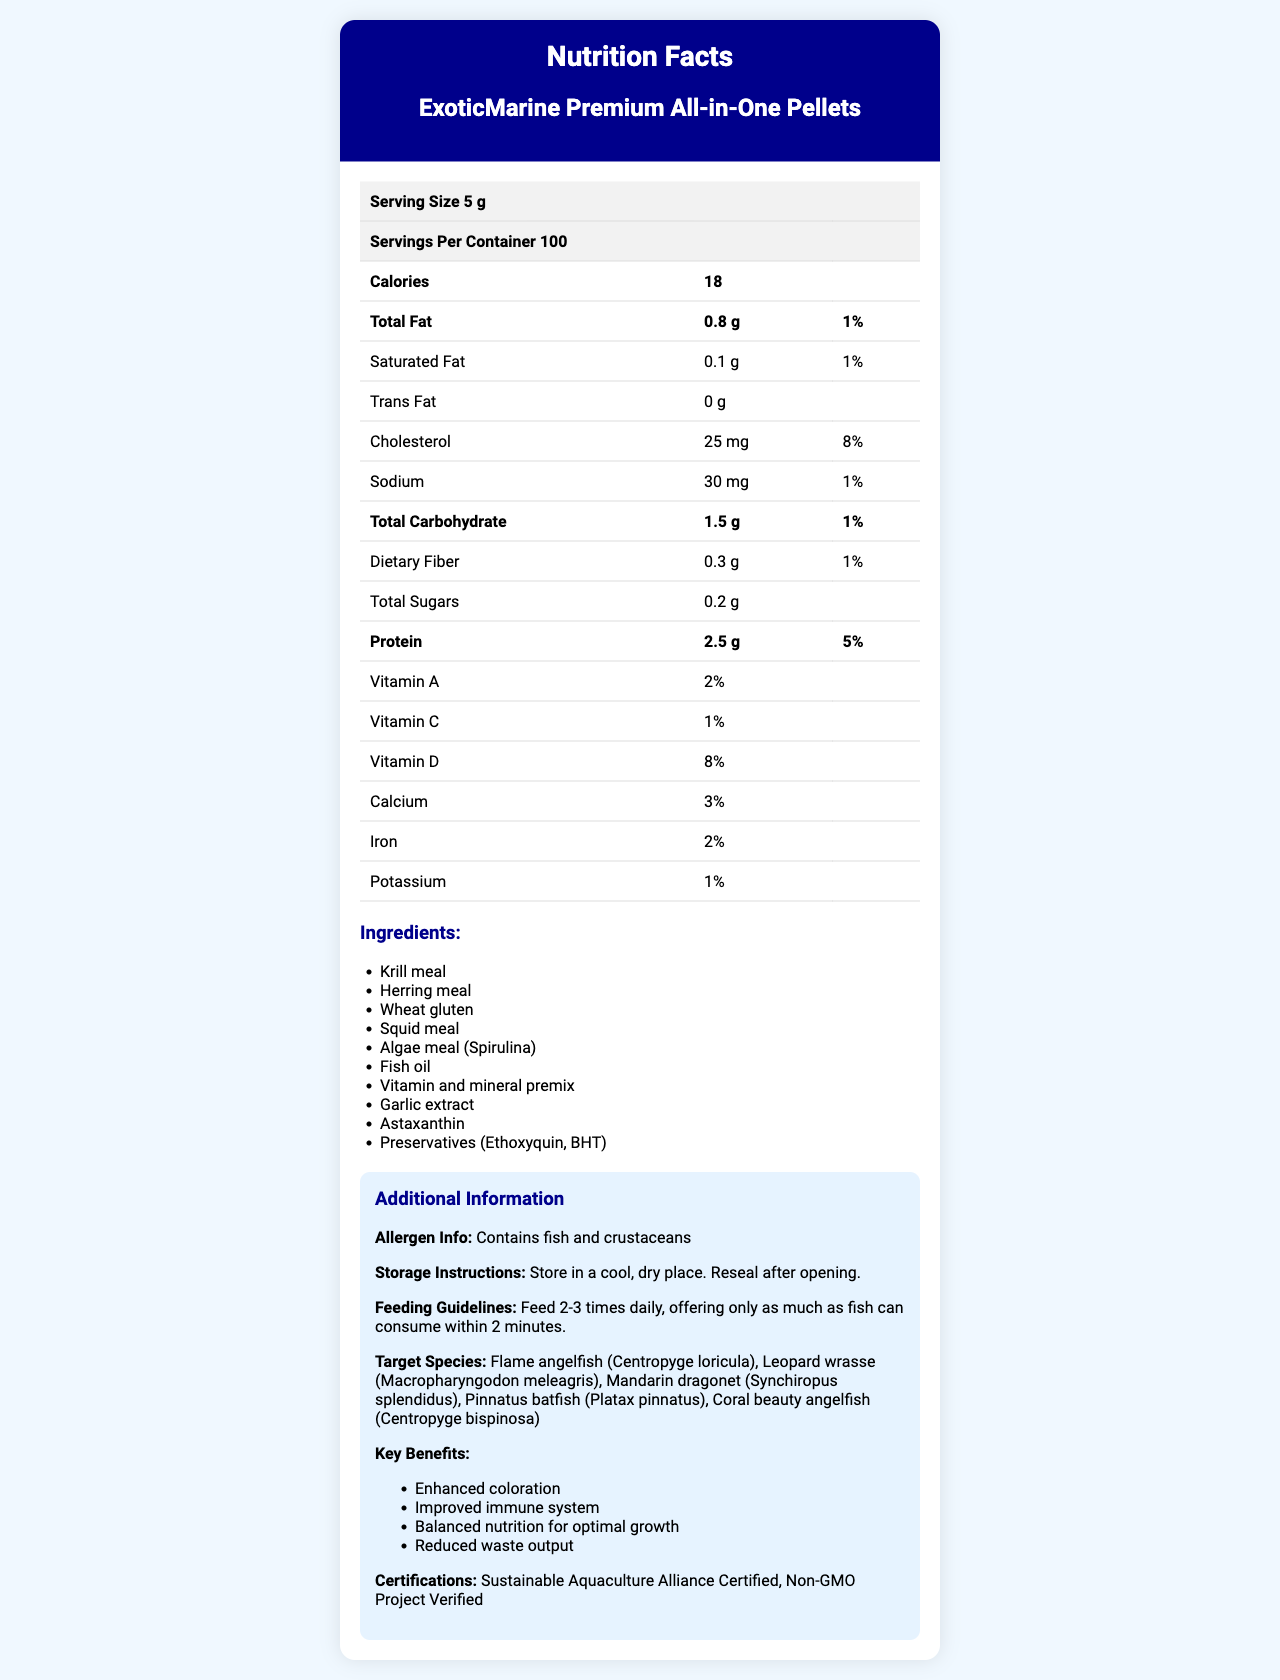what is the serving size? The document mentions "Serving Size 5 g" at the top of the nutrition facts table.
Answer: 5 g how many servings are there per container? The document shows "Servings Per Container 100" right after the serving size.
Answer: 100 how many calories are in a serving? The document lists "Calories" as 18 in the bold text at the top of the nutrition details.
Answer: 18 what is the total fat content in a serving? The total fat content per serving is mentioned as "Total Fat 0.8 g" right below the "Calories" entry.
Answer: 0.8 g how much dietary fiber does each serving contain? The document lists "Dietary Fiber" as 0.3 g under the "Total Carbohydrate" section.
Answer: 0.3 g how much protein does each serving provide? The amount of protein per serving is shown as "Protein 2.5 g".
Answer: 2.5 g which vitamin has the highest daily value percentage in a serving? Among the listed vitamins, "Vitamin D" has the highest daily value percentage at 8%.
Answer: Vitamin D what ingredients are included in the product? A. Krill meal, Herring meal, Wheat gluten B. Algae meal, Fish oil, Shrimp extract C. Astaxanthin, Honey, Pea protein The ingredients listed in the document include "Krill meal, Herring meal, Wheat gluten," among others, but options B and C contain incorrect or partial lists.
Answer: A. Krill meal, Herring meal, Wheat gluten what are the key benefits of this product? A. Enhanced coloration, Improved immune system B. Neutral pH, Increased algae growth C. Reduced cost, Enhanced iron absorption The document lists "Enhanced coloration, Improved immune system" as key benefits along with balanced nutrition for optimal growth and reduced waste output.
Answer: A. Enhanced coloration, Improved immune system does the product contain trans fat? The document specifies "Trans Fat 0 g," indicating no trans fat in the product.
Answer: No what certifications does the product have? The document lists "Sustainable Aquaculture Alliance Certified" and "Non-GMO Project Verified" as certifications.
Answer: Sustainable Aquaculture Alliance Certified, Non-GMO Project Verified are there any allergen warnings provided? The document provides an allergen warning stating "Contains fish and crustaceans."
Answer: Yes what are the storage instructions for this product? The document lists "Store in a cool, dry place. Reseal after opening." under storage instructions.
Answer: Store in a cool, dry place. Reseal after opening. how often should the pellets be fed to fish? The feeding guidelines suggest "Feed 2-3 times daily, offering only as much as fish can consume within 2 minutes."
Answer: 2-3 times daily, offering only as much as fish can consume within 2 minutes which of the following species is NOT a target species for this product? A. Flame angelfish B. Clownfish C. Mandarin dragonet The document lists several target species, including "Flame angelfish" and "Mandarin dragonet," but not "Clownfish."
Answer: B. Clownfish what is the omega-3 fatty acids content per serving? The document mentions "Omega 3 fatty acids 0.3 g" under the nutritional information.
Answer: 0.3 g what is the importance of astaxanthin in the formula? Astaxanthin is included for enhanced coloration, as noted in the key benefits section.
Answer: Enhanced coloration what is the main idea of the document? The document outlines the nutritional profile of the product, including calories, macronutrients, vitamins, minerals, and special ingredients, along with the benefits, targeted species, and usage instructions.
Answer: The document provides comprehensive nutrition facts and additional information about ExoticMarine Premium All-in-One Pellets, highlighting their nutritional contents, ingredients, key benefits, certifications, target species, and feeding guidelines. are preservatives used in the product? The document lists preservatives (Ethoxyquin, BHT) among the ingredients.
Answer: Yes what is the total carbohydrate content in a serving? The document lists "Total Carbohydrate 1.5 g" under the total carbohydrate section.
Answer: 1.5 g how much saturated fat does each serving contain? The document lists "Saturated Fat" as 0.1 g under the "Total Fat" section.
Answer: 0.1 g what species is mentioned under the target species but might not be known commonly? Leopard wrasse is less commonly known compared to other named species.
Answer: Leopard wrasse (Macropharyngodon meleagris) does the product have any vitamin B12? The document does not provide any information about the vitamin B12 content.
Answer: Not enough information 